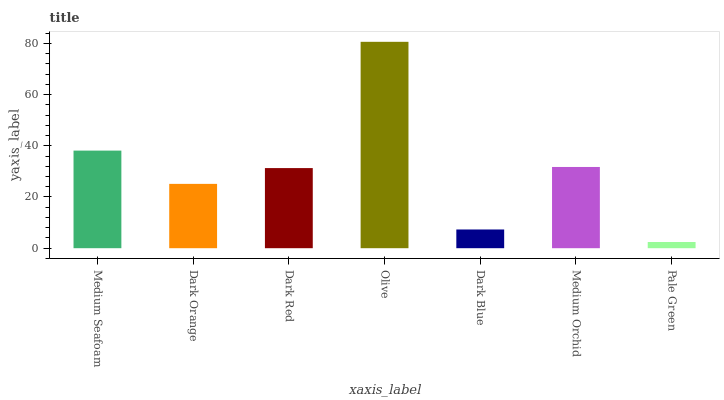Is Pale Green the minimum?
Answer yes or no. Yes. Is Olive the maximum?
Answer yes or no. Yes. Is Dark Orange the minimum?
Answer yes or no. No. Is Dark Orange the maximum?
Answer yes or no. No. Is Medium Seafoam greater than Dark Orange?
Answer yes or no. Yes. Is Dark Orange less than Medium Seafoam?
Answer yes or no. Yes. Is Dark Orange greater than Medium Seafoam?
Answer yes or no. No. Is Medium Seafoam less than Dark Orange?
Answer yes or no. No. Is Dark Red the high median?
Answer yes or no. Yes. Is Dark Red the low median?
Answer yes or no. Yes. Is Medium Seafoam the high median?
Answer yes or no. No. Is Dark Blue the low median?
Answer yes or no. No. 